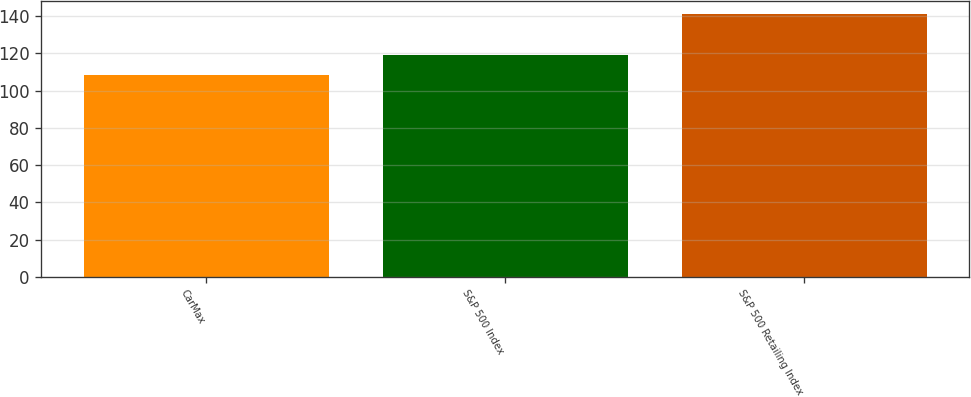Convert chart. <chart><loc_0><loc_0><loc_500><loc_500><bar_chart><fcel>CarMax<fcel>S&P 500 Index<fcel>S&P 500 Retailing Index<nl><fcel>108.59<fcel>119.27<fcel>141.17<nl></chart> 